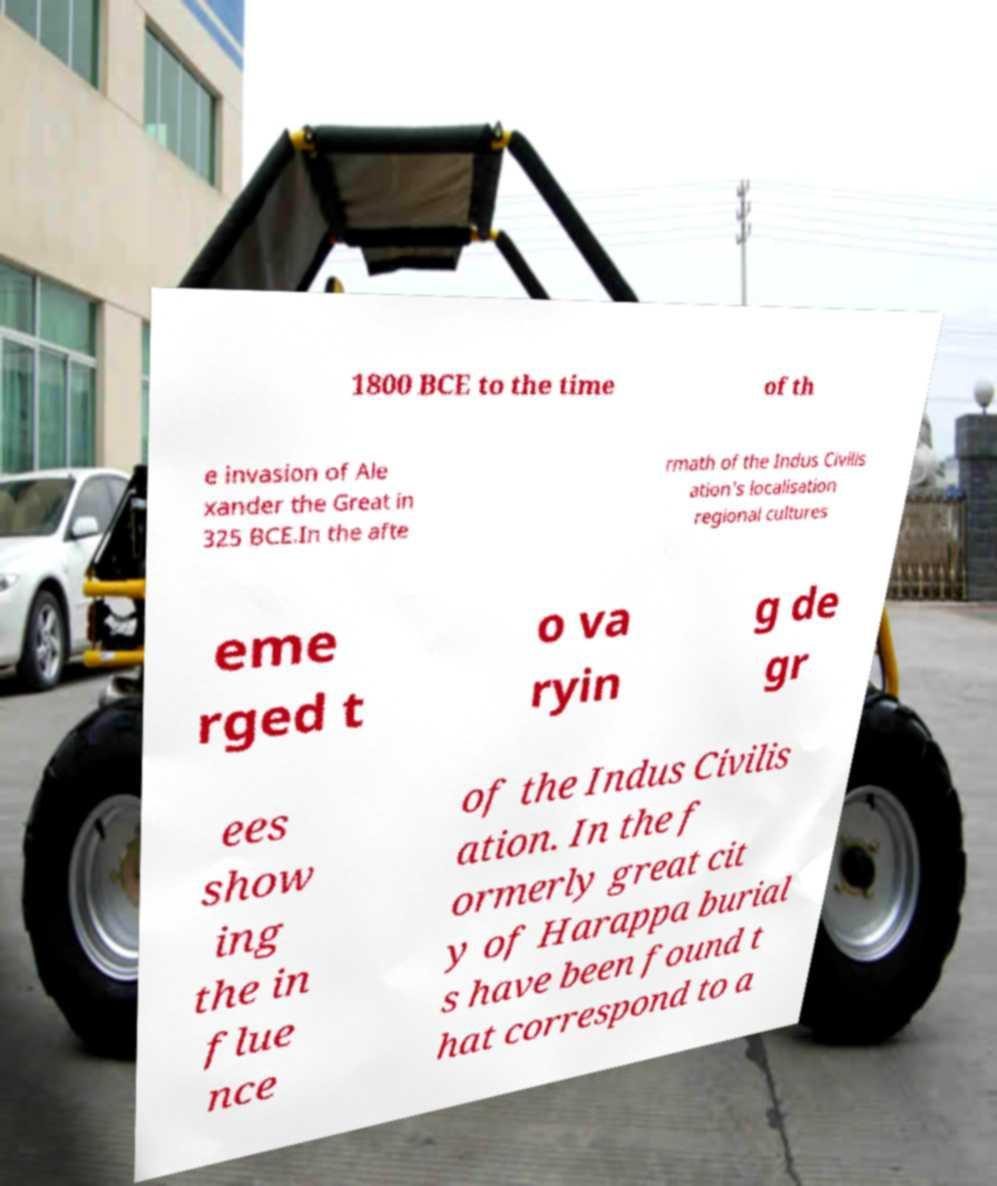Could you extract and type out the text from this image? 1800 BCE to the time of th e invasion of Ale xander the Great in 325 BCE.In the afte rmath of the Indus Civilis ation's localisation regional cultures eme rged t o va ryin g de gr ees show ing the in flue nce of the Indus Civilis ation. In the f ormerly great cit y of Harappa burial s have been found t hat correspond to a 